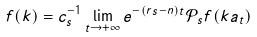<formula> <loc_0><loc_0><loc_500><loc_500>f ( k ) = c _ { s } ^ { - 1 } \lim _ { t \to + \infty } e ^ { - ( r s - n ) t } \mathcal { P } _ { s } f ( k a _ { t } )</formula> 